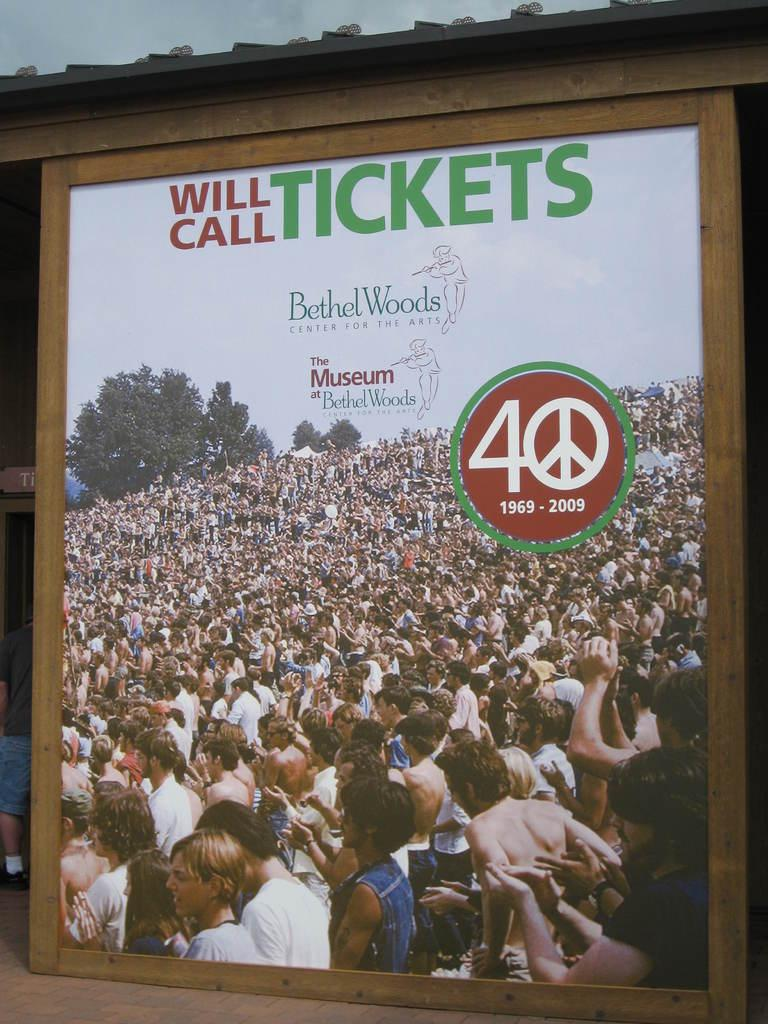What is the main object in the image with text and numbers? There is a board with text and numbers in the image. What else can be seen on the board besides text and numbers? The board has pictures of people and a tree depicted on it. Can you describe the person in the image? There is a person in the image, but no specific details about their appearance or actions are provided. What type of structure is visible in the image? There is a house in the image. What is visible in the background of the image? The sky is visible in the image. What type of news can be heard coming from the cent depicted on the board? There is no cent or news depicted on the board; it features a board with text, numbers, pictures of people, and a tree. 